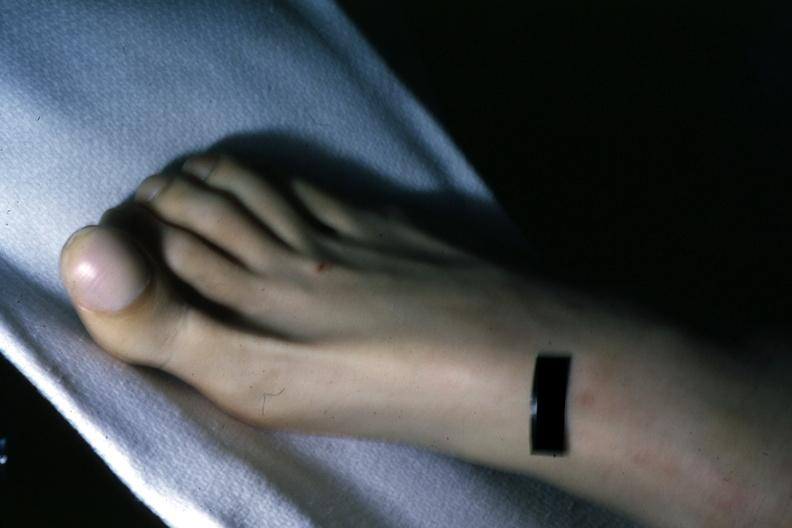re trophic changes present?
Answer the question using a single word or phrase. No 